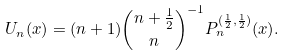<formula> <loc_0><loc_0><loc_500><loc_500>U _ { n } ( x ) = ( n + 1 ) \binom { n + \frac { 1 } { 2 } } { n } ^ { - 1 } P _ { n } ^ { ( \frac { 1 } { 2 } , \frac { 1 } { 2 } ) } ( x ) .</formula> 